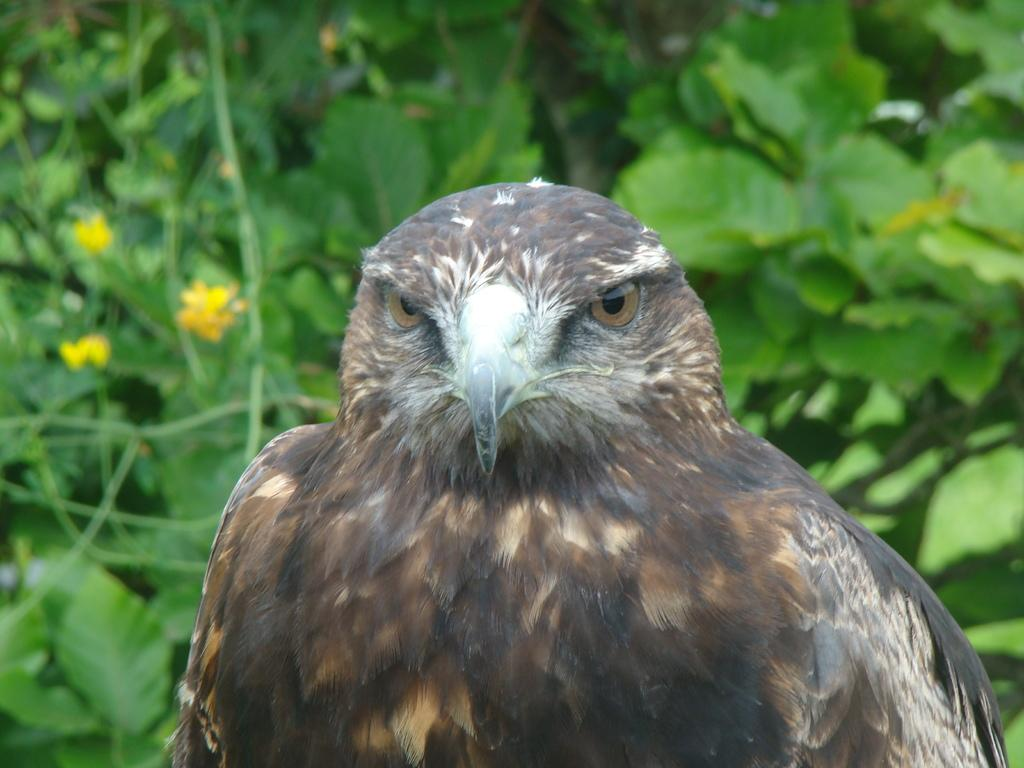What is the main subject in the center of the image? There is an eagle in the center of the image. What can be seen in the background of the image? There are leaves visible in the background of the image. What type of glue is being used to hold the border in the image? There is no border or glue present in the image; it features an eagle and leaves in the background. What time of day is depicted in the image? The time of day is not indicated in the image; it only shows an eagle and leaves in the background. 